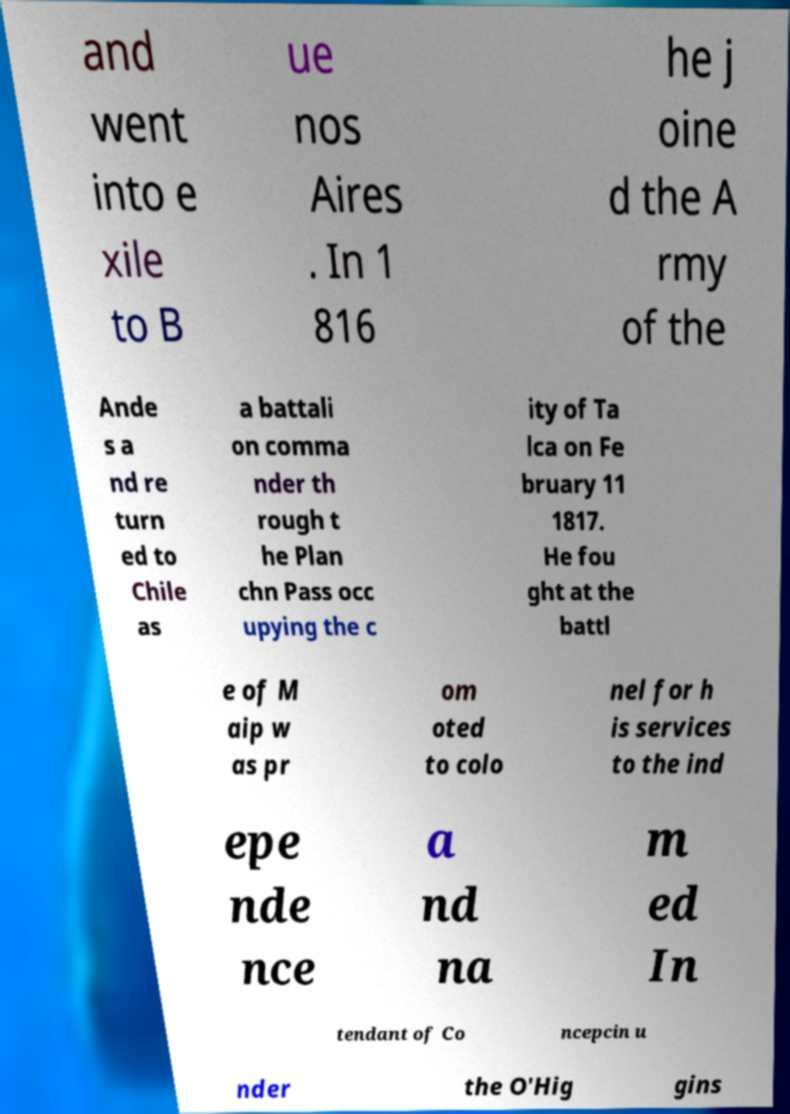What messages or text are displayed in this image? I need them in a readable, typed format. and went into e xile to B ue nos Aires . In 1 816 he j oine d the A rmy of the Ande s a nd re turn ed to Chile as a battali on comma nder th rough t he Plan chn Pass occ upying the c ity of Ta lca on Fe bruary 11 1817. He fou ght at the battl e of M aip w as pr om oted to colo nel for h is services to the ind epe nde nce a nd na m ed In tendant of Co ncepcin u nder the O'Hig gins 